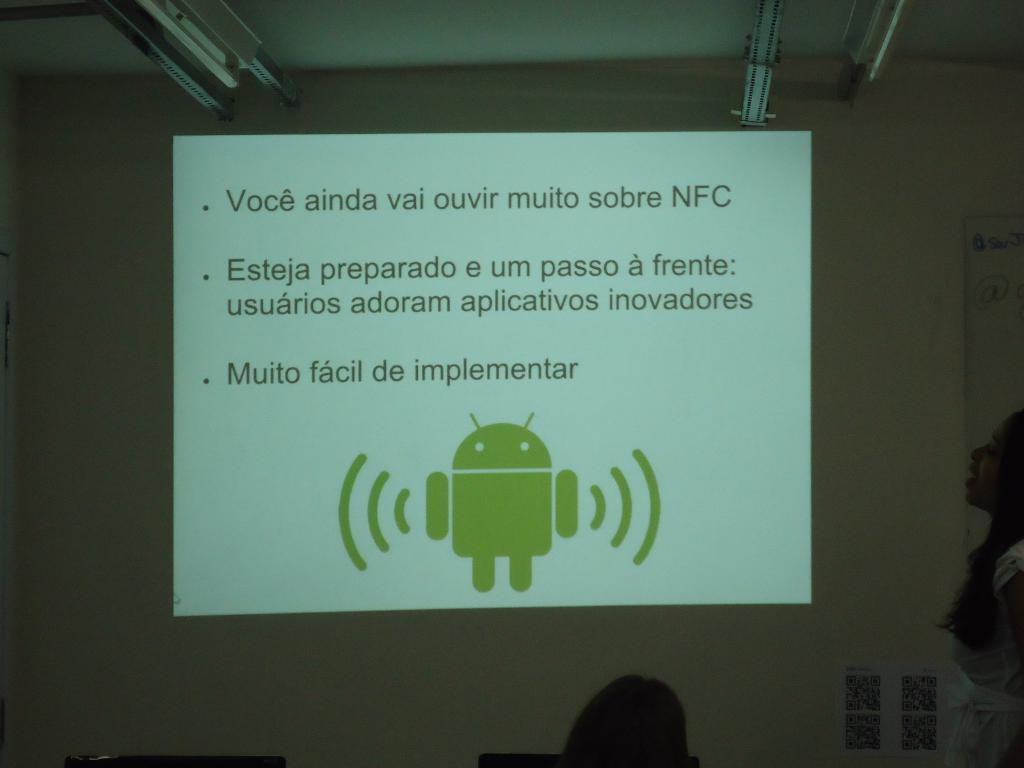Please provide a concise description of this image. This picture is a black and white image. In this image we can see some objects attached to the ceiling, one object on the left side of the image, one white board with text attached to the wall on the right side of the image, two black objects on the bottom of the image, one poster with images attached to the wall, one person's head on the bottom of the image, projecting text and image on the wall in the middle of the image. One woman standing and talking on the right side of the image. 